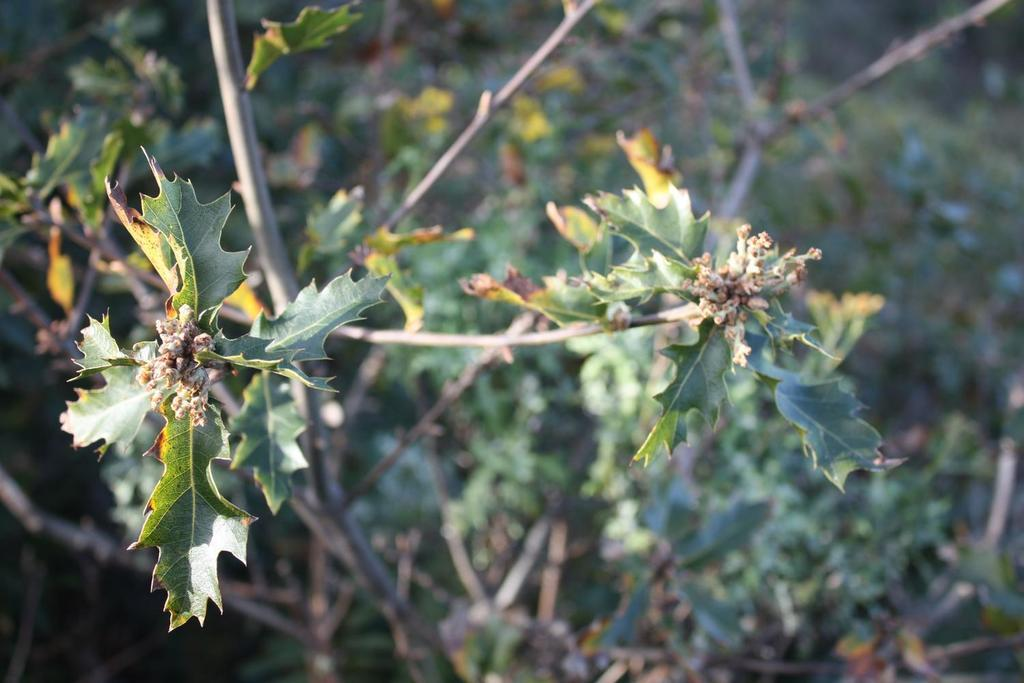What type of vegetation can be seen in the image? There are trees in the image. How would you describe the background of the image? The background of the image is blurry. What type of music can be heard coming from the geese in the image? There are no geese present in the image, so it's not possible to determine what, if any, music might be heard. 